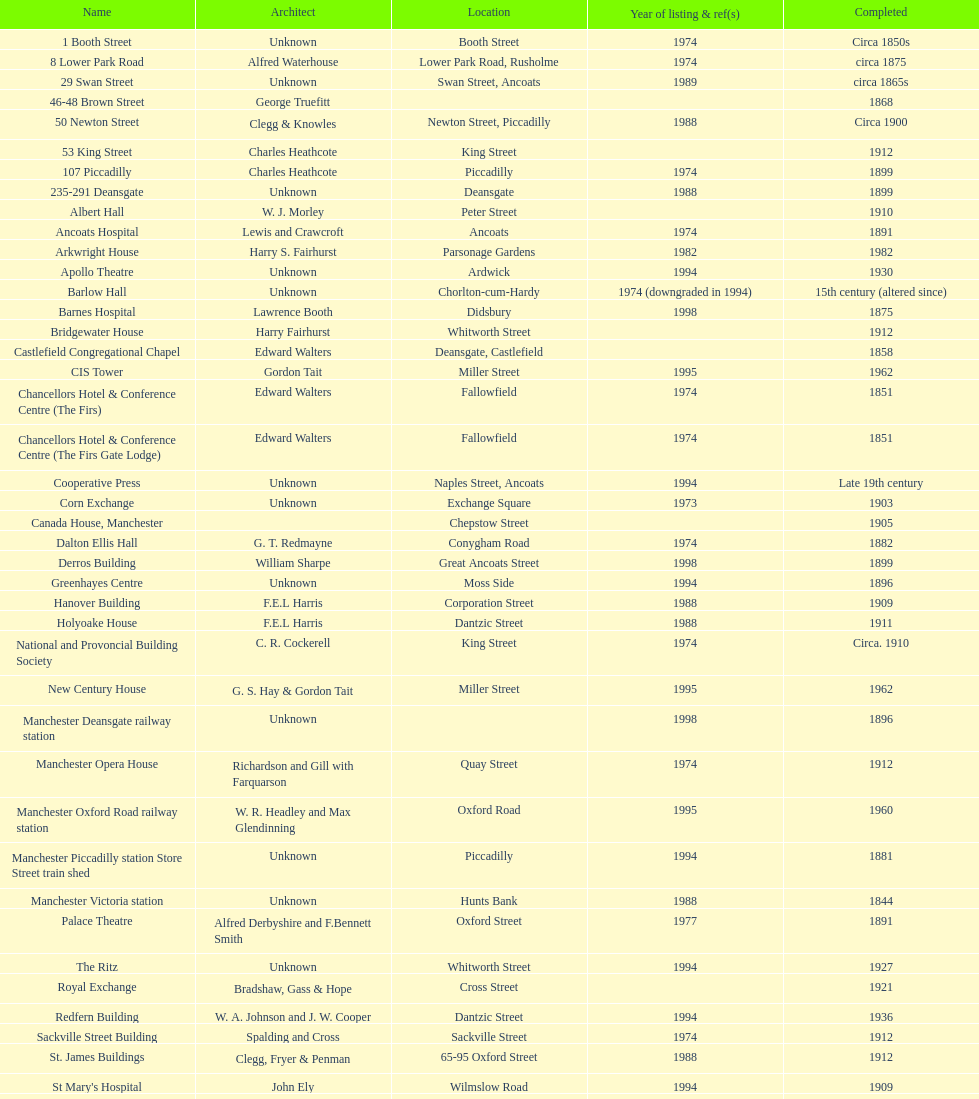How many buildings had alfred waterhouse as their architect? 3. 